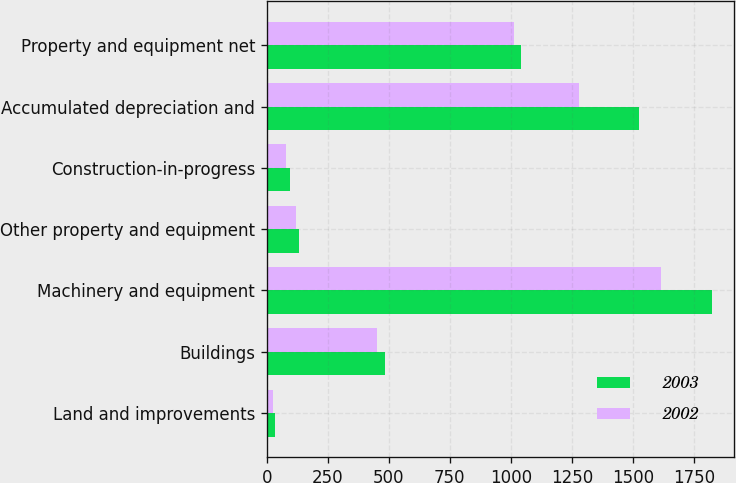Convert chart. <chart><loc_0><loc_0><loc_500><loc_500><stacked_bar_chart><ecel><fcel>Land and improvements<fcel>Buildings<fcel>Machinery and equipment<fcel>Other property and equipment<fcel>Construction-in-progress<fcel>Accumulated depreciation and<fcel>Property and equipment net<nl><fcel>2003<fcel>31.9<fcel>485.5<fcel>1823.6<fcel>131.7<fcel>93.5<fcel>1523.8<fcel>1042.4<nl><fcel>2002<fcel>27.4<fcel>449.9<fcel>1616<fcel>119.6<fcel>79.6<fcel>1279.5<fcel>1013<nl></chart> 